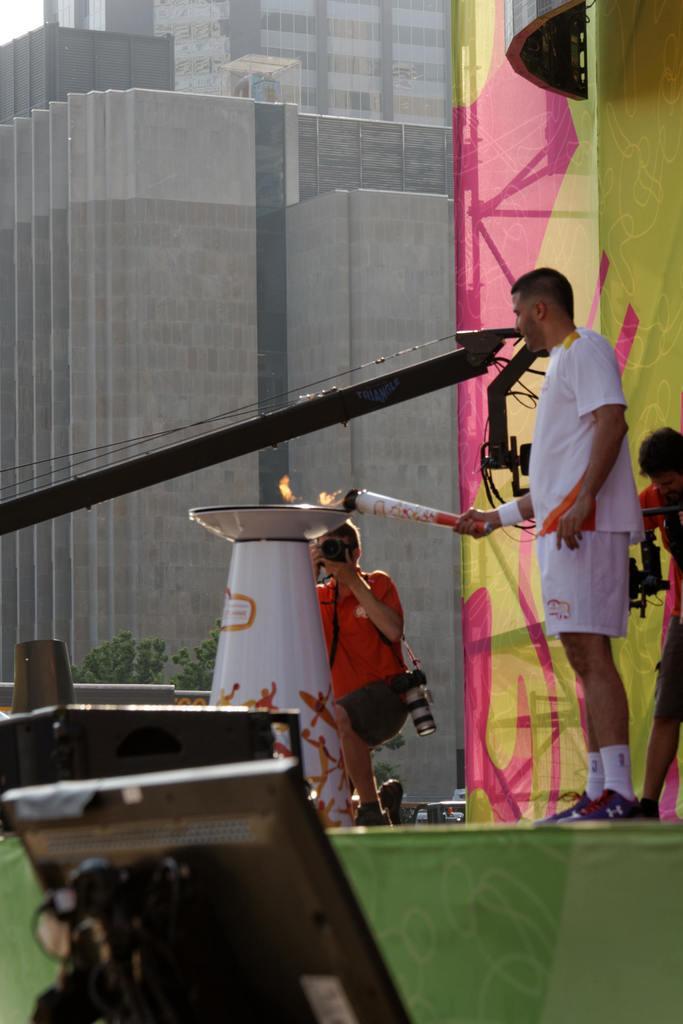How would you summarize this image in a sentence or two? Man is standing holding an object, here there is a building, a person is holding camera, this is monitor. 